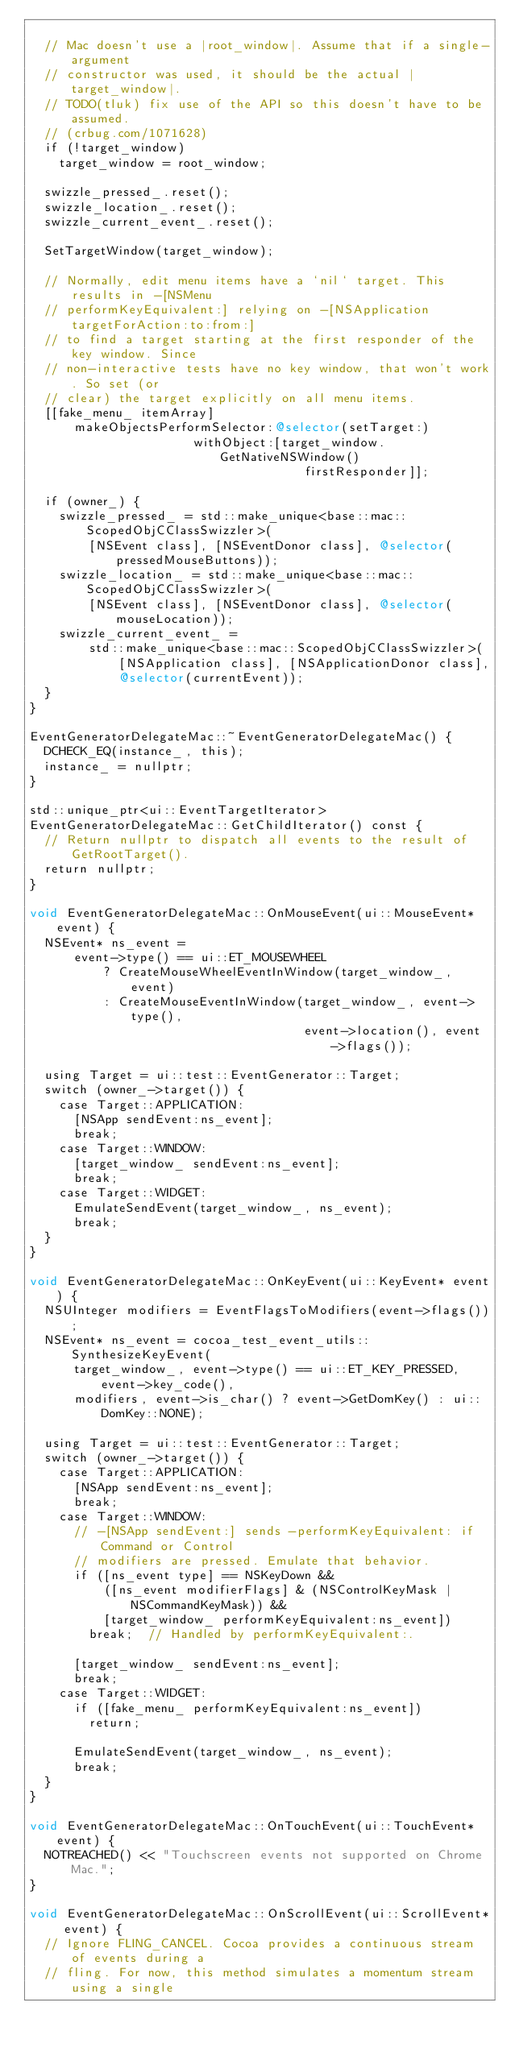Convert code to text. <code><loc_0><loc_0><loc_500><loc_500><_ObjectiveC_>
  // Mac doesn't use a |root_window|. Assume that if a single-argument
  // constructor was used, it should be the actual |target_window|.
  // TODO(tluk) fix use of the API so this doesn't have to be assumed.
  // (crbug.com/1071628)
  if (!target_window)
    target_window = root_window;

  swizzle_pressed_.reset();
  swizzle_location_.reset();
  swizzle_current_event_.reset();

  SetTargetWindow(target_window);

  // Normally, edit menu items have a `nil` target. This results in -[NSMenu
  // performKeyEquivalent:] relying on -[NSApplication targetForAction:to:from:]
  // to find a target starting at the first responder of the key window. Since
  // non-interactive tests have no key window, that won't work. So set (or
  // clear) the target explicitly on all menu items.
  [[fake_menu_ itemArray]
      makeObjectsPerformSelector:@selector(setTarget:)
                      withObject:[target_window.GetNativeNSWindow()
                                     firstResponder]];

  if (owner_) {
    swizzle_pressed_ = std::make_unique<base::mac::ScopedObjCClassSwizzler>(
        [NSEvent class], [NSEventDonor class], @selector(pressedMouseButtons));
    swizzle_location_ = std::make_unique<base::mac::ScopedObjCClassSwizzler>(
        [NSEvent class], [NSEventDonor class], @selector(mouseLocation));
    swizzle_current_event_ =
        std::make_unique<base::mac::ScopedObjCClassSwizzler>(
            [NSApplication class], [NSApplicationDonor class],
            @selector(currentEvent));
  }
}

EventGeneratorDelegateMac::~EventGeneratorDelegateMac() {
  DCHECK_EQ(instance_, this);
  instance_ = nullptr;
}

std::unique_ptr<ui::EventTargetIterator>
EventGeneratorDelegateMac::GetChildIterator() const {
  // Return nullptr to dispatch all events to the result of GetRootTarget().
  return nullptr;
}

void EventGeneratorDelegateMac::OnMouseEvent(ui::MouseEvent* event) {
  NSEvent* ns_event =
      event->type() == ui::ET_MOUSEWHEEL
          ? CreateMouseWheelEventInWindow(target_window_, event)
          : CreateMouseEventInWindow(target_window_, event->type(),
                                     event->location(), event->flags());

  using Target = ui::test::EventGenerator::Target;
  switch (owner_->target()) {
    case Target::APPLICATION:
      [NSApp sendEvent:ns_event];
      break;
    case Target::WINDOW:
      [target_window_ sendEvent:ns_event];
      break;
    case Target::WIDGET:
      EmulateSendEvent(target_window_, ns_event);
      break;
  }
}

void EventGeneratorDelegateMac::OnKeyEvent(ui::KeyEvent* event) {
  NSUInteger modifiers = EventFlagsToModifiers(event->flags());
  NSEvent* ns_event = cocoa_test_event_utils::SynthesizeKeyEvent(
      target_window_, event->type() == ui::ET_KEY_PRESSED, event->key_code(),
      modifiers, event->is_char() ? event->GetDomKey() : ui::DomKey::NONE);

  using Target = ui::test::EventGenerator::Target;
  switch (owner_->target()) {
    case Target::APPLICATION:
      [NSApp sendEvent:ns_event];
      break;
    case Target::WINDOW:
      // -[NSApp sendEvent:] sends -performKeyEquivalent: if Command or Control
      // modifiers are pressed. Emulate that behavior.
      if ([ns_event type] == NSKeyDown &&
          ([ns_event modifierFlags] & (NSControlKeyMask | NSCommandKeyMask)) &&
          [target_window_ performKeyEquivalent:ns_event])
        break;  // Handled by performKeyEquivalent:.

      [target_window_ sendEvent:ns_event];
      break;
    case Target::WIDGET:
      if ([fake_menu_ performKeyEquivalent:ns_event])
        return;

      EmulateSendEvent(target_window_, ns_event);
      break;
  }
}

void EventGeneratorDelegateMac::OnTouchEvent(ui::TouchEvent* event) {
  NOTREACHED() << "Touchscreen events not supported on Chrome Mac.";
}

void EventGeneratorDelegateMac::OnScrollEvent(ui::ScrollEvent* event) {
  // Ignore FLING_CANCEL. Cocoa provides a continuous stream of events during a
  // fling. For now, this method simulates a momentum stream using a single</code> 